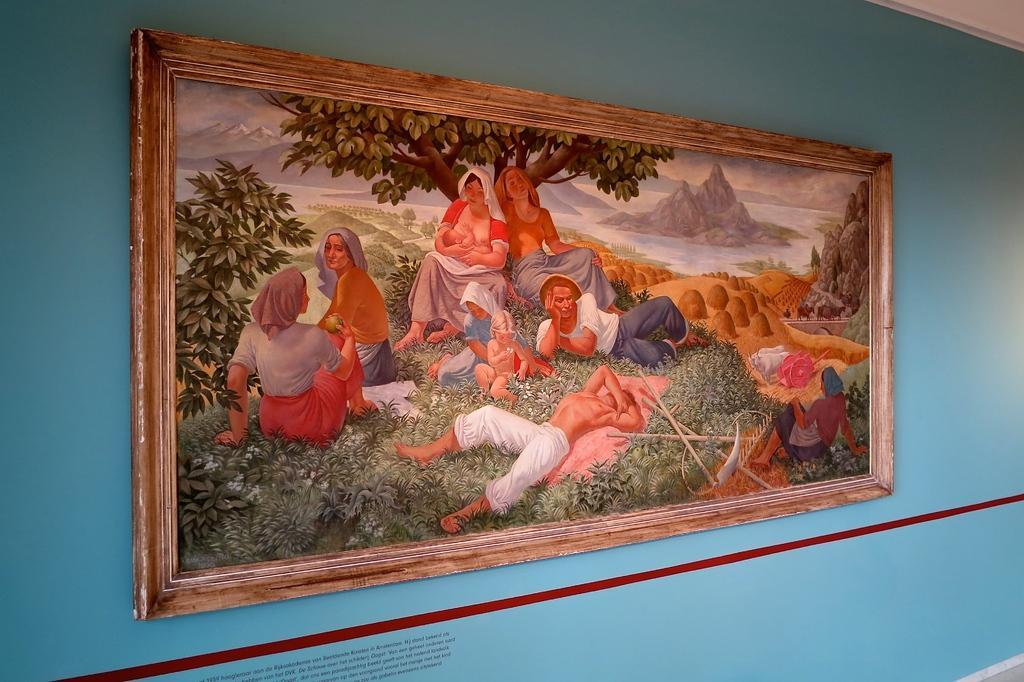Can you describe this image briefly? In this image I can see a depiction picture where I can see number of people and trees. I can also see blue color wall. 